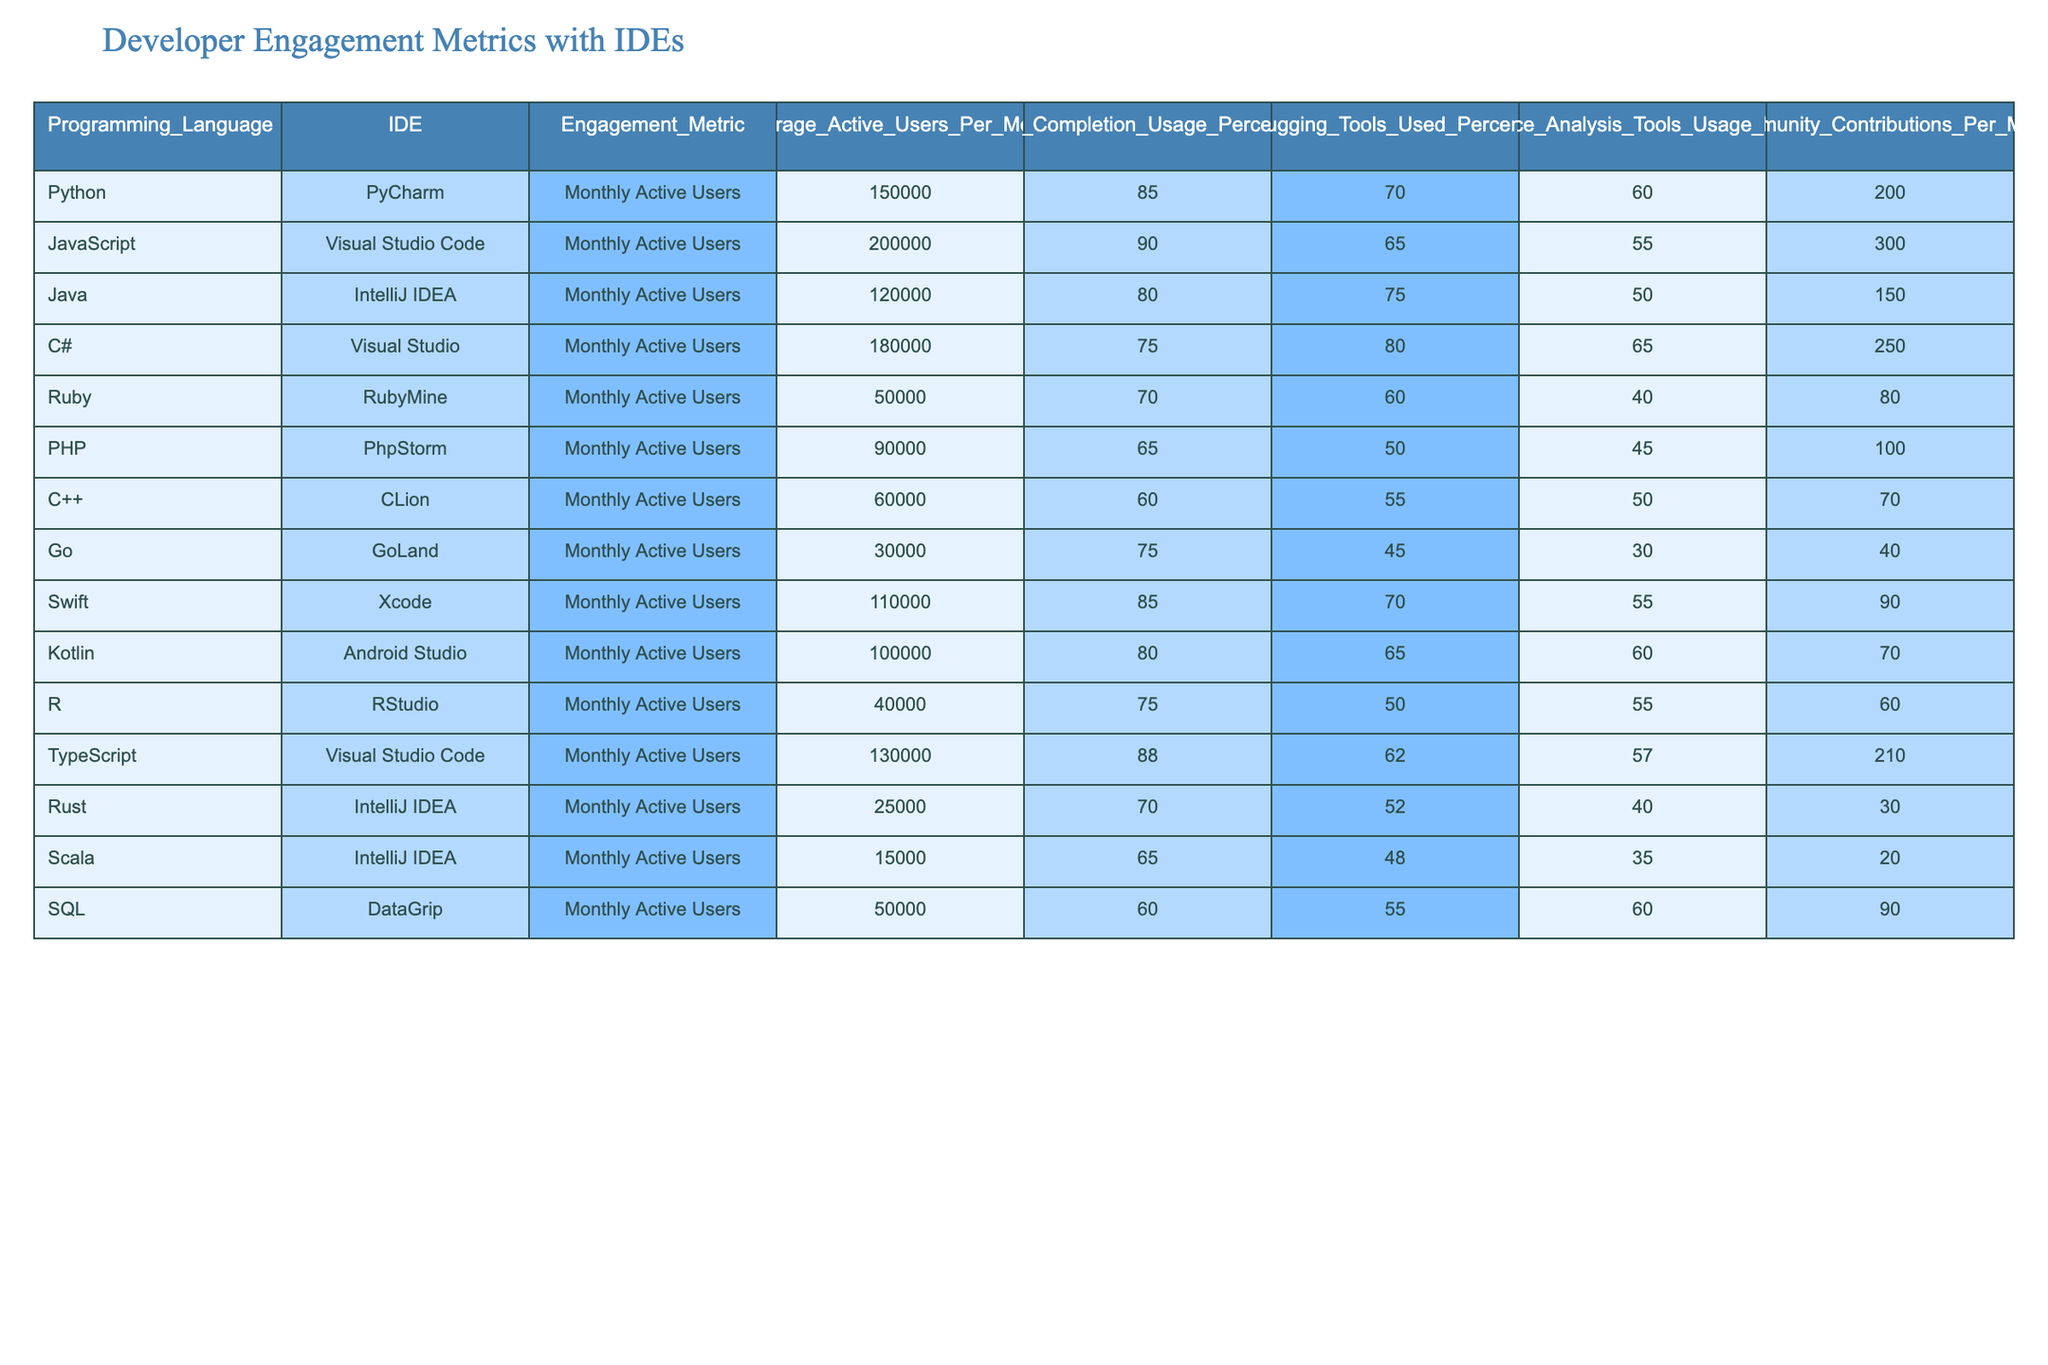What is the average number of monthly active users for Python and Ruby? The monthly active users for Python is 150000 and for Ruby, it is 50000. To find the average, we add these two values: 150000 + 50000 = 200000. Then, we divide by 2 to get the average: 200000 / 2 = 100000.
Answer: 100000 Which IDE has the highest percentage of code completion usage? From the table, Visual Studio Code has a code completion usage percentage of 90, while the next highest is PyCharm with 85. Therefore, Visual Studio Code has the highest percentage of code completion usage.
Answer: Visual Studio Code Is the percentage of community contributions for Swift greater than that of Go? The table shows that Swift has 90 community contributions per month and Go has 40. Since 90 is greater than 40, the statement is true.
Answer: Yes What is the total number of community contributions per month for Java, C#, and Kotlin? To find the total contributions for these three programming languages, we sum up the contributions: 150 for Java, 250 for C#, and 70 for Kotlin. So, 150 + 250 + 70 = 470.
Answer: 470 Do Python users utilize debugging tools more than PHP users? The debugging tools usage percentage for Python is 70%, while for PHP it is 50%. Since 70% is greater than 50%, the answer is yes.
Answer: Yes What is the average performance analysis tools usage percentage for C++ and R? The performance analysis tools usage percentage for C++ is 50% and for R it is 55%. To find the average, we sum these values: 50 + 55 = 105. We then divide the sum by 2, resulting in 105 / 2 = 52.5.
Answer: 52.5 Which programming language has the least number of monthly active users? By examining the monthly active users for all listed programming languages, we see that Go has the least number with 30000 users.
Answer: Go If we consider only IDEs from JetBrains, what is their average monthly active users? JetBrains IDEs include PyCharm, IntelliJ IDEA, and RubyMine with monthly active users of 150000, 120000, and 50000 respectively. Summing these gives us 150000 + 120000 + 50000 = 320000. Now, divide by the number of IDEs (3): 320000 / 3 = 106666.67.
Answer: 106666.67 